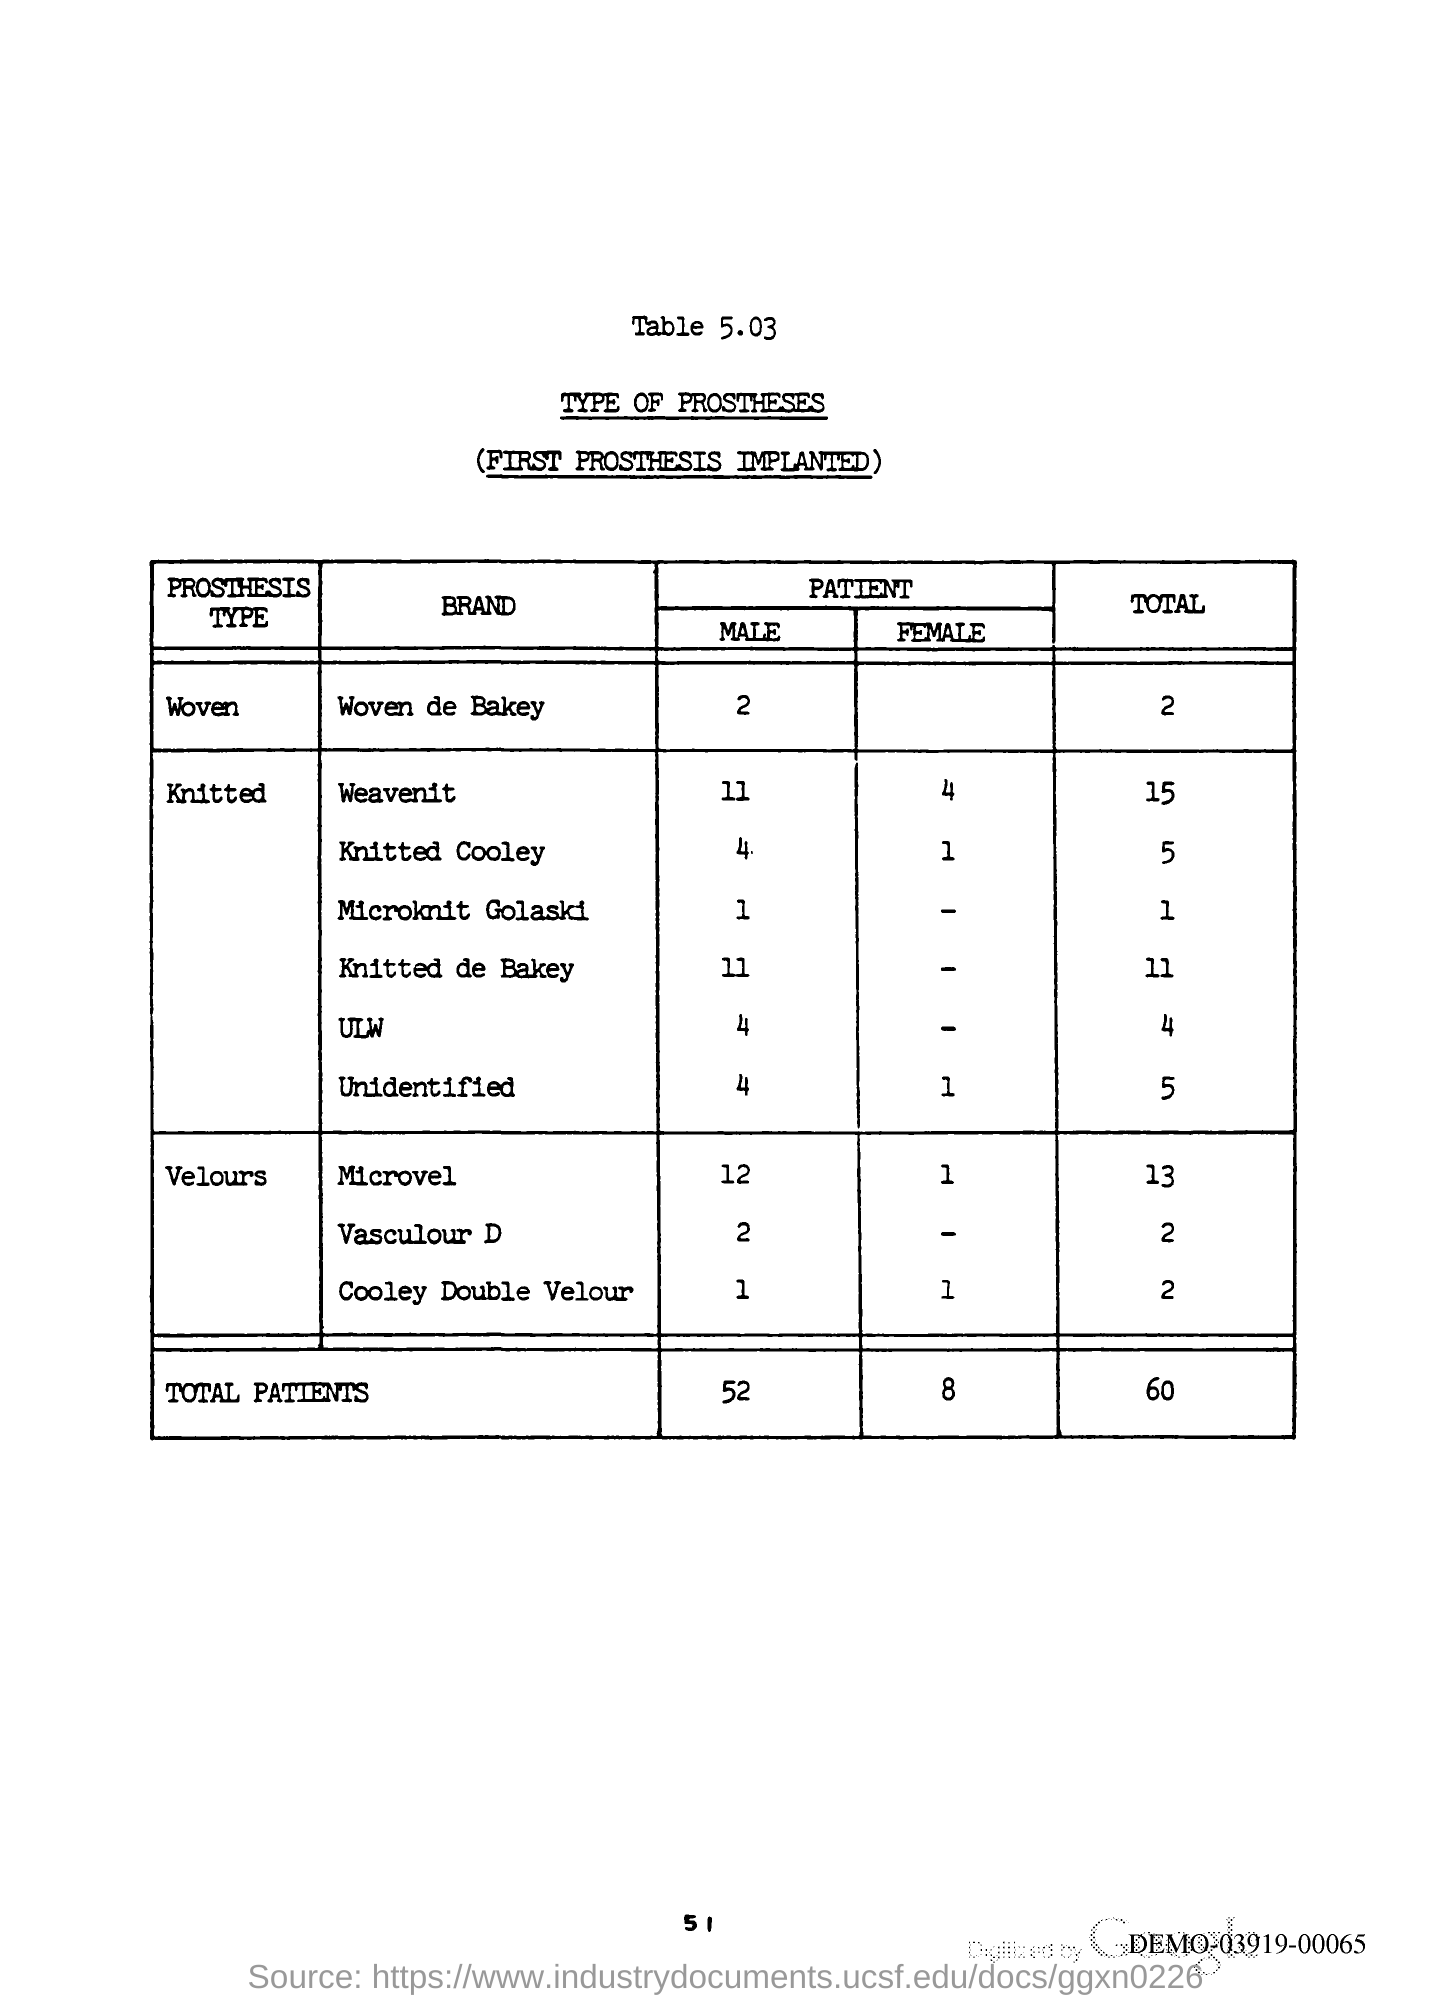What is the Page Number?
Give a very brief answer. 51. 